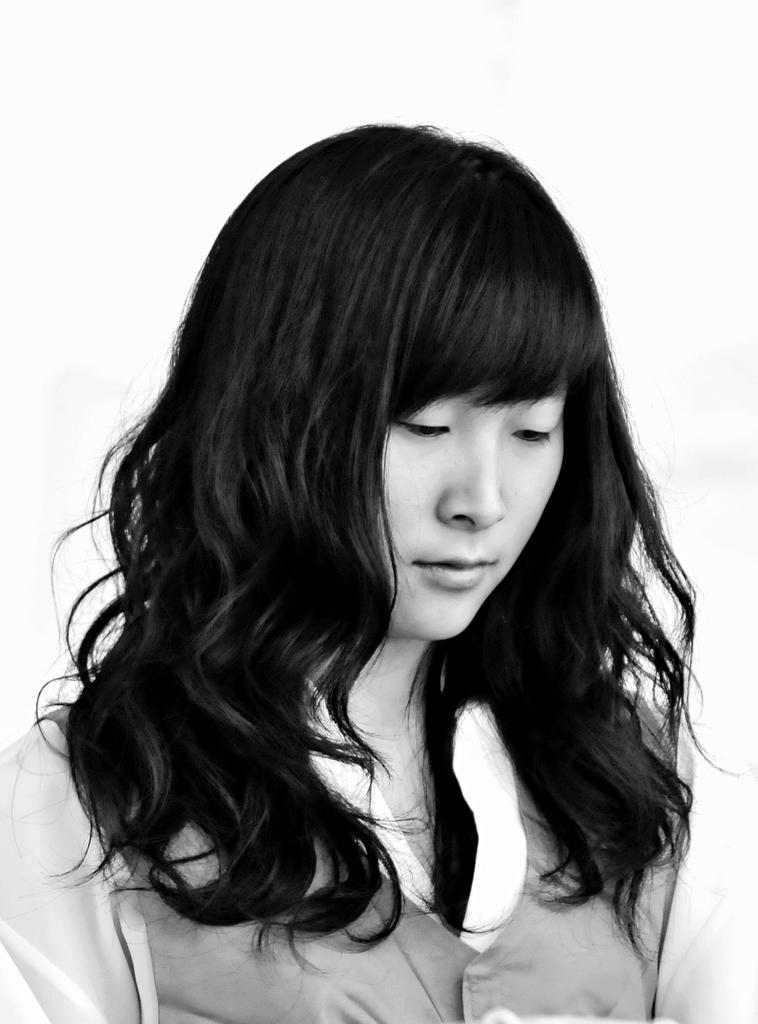What is the color scheme of the image? The image is black and white. Can you describe the main subject of the image? There is a woman in the image. What type of pin is the woman wearing in the image? There is no pin visible on the woman in the image. What does the woman's voice sound like in the image? The image is not a video or audio recording, so there is no voice to describe. 